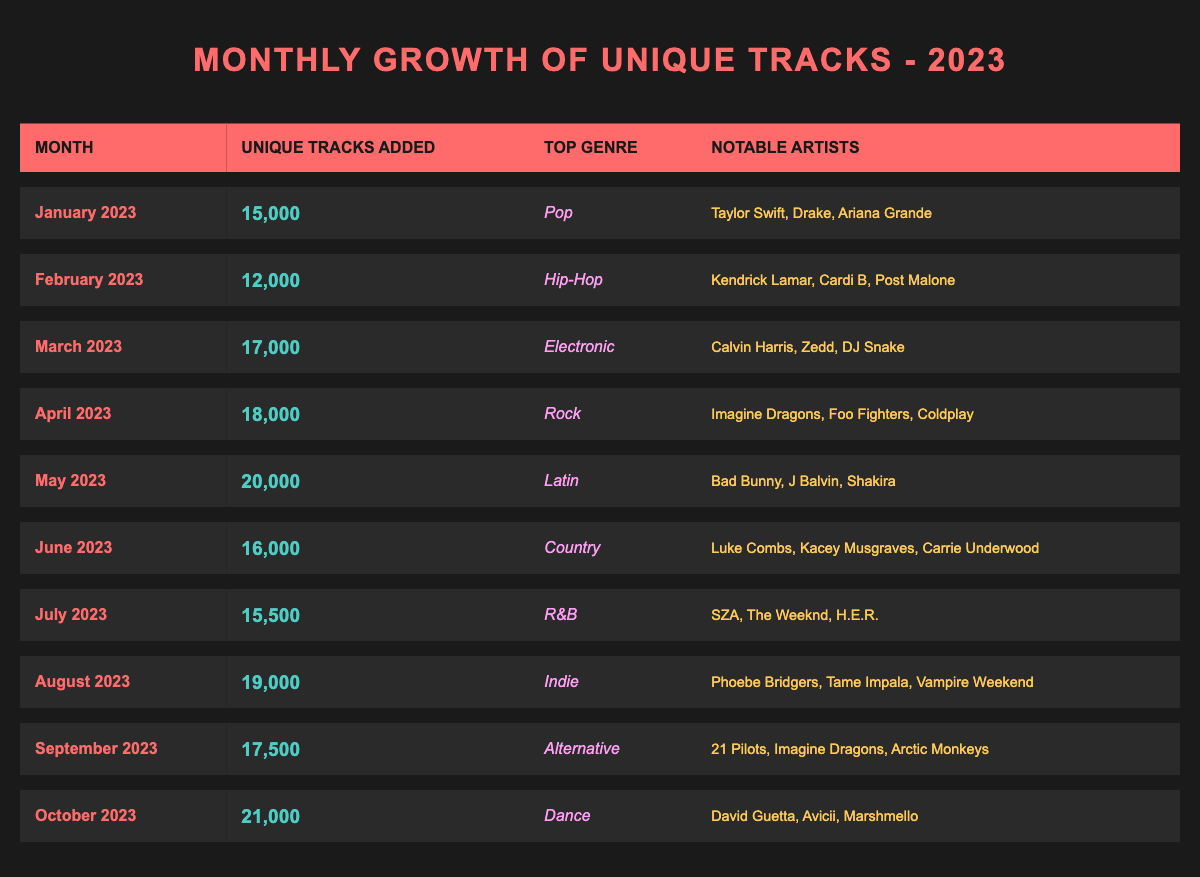What was the month with the highest number of unique tracks added? By examining the "Unique Tracks Added" column, I can see that October 2023 has the highest value of 21,000 unique tracks added.
Answer: October 2023 Which genre was the top genre in May 2023? Referring to the "Top Genre" column for May 2023, it shows Latin as the leading genre for that month.
Answer: Latin How many unique tracks were added in total from January to March 2023? To find the total, I add the unique tracks for January (15,000), February (12,000), and March (17,000): 15,000 + 12,000 + 17,000 = 44,000.
Answer: 44,000 Was there a decrease in the number of unique tracks added from January to February 2023? I compare the unique tracks added in January (15,000) to those in February (12,000). Since 12,000 is less than 15,000, there was indeed a decrease.
Answer: Yes What is the average number of unique tracks added from June to August 2023? First, I need to calculate the total for June (16,000), July (15,500), and August (19,000): 16,000 + 15,500 + 19,000 = 50,500. Then I divide by 3 (the number of months): 50,500 / 3 = 16,833.33.
Answer: 16,833 (rounded) Which month had more unique tracks added, July or September 2023? July saw 15,500 unique tracks added, while September had 17,500. Since 17,500 is greater than 15,500, September had more added tracks.
Answer: September What was the difference in unique tracks added between the months with the lowest and highest additions? The lowest addition was in February 2023 with 12,000 tracks, and the highest was in October 2023 with 21,000 tracks. The difference is 21,000 - 12,000 = 9,000.
Answer: 9,000 Which notable artist is associated with the top genre in April 2023? For April 2023, the top genre is Rock, and notable artists listed are Imagine Dragons, Foo Fighters, and Coldplay.
Answer: Imagine Dragons, Foo Fighters, Coldplay How many total unique tracks were added from May to October 2023? I need to find the total for May (20,000), June (16,000), July (15,500), August (19,000), September (17,500), and October (21,000). The total is: 20,000 + 16,000 + 15,500 + 19,000 + 17,500 + 21,000 = 109,000.
Answer: 109,000 Is it true that the top artist in the top genre of March 2023 was Calvin Harris? In March 2023, the top genre was Electronic, and Calvin Harris is listed as a notable artist for that genre, indicating that the statement is true.
Answer: Yes What genre had the highest number of unique tracks added in a single month in 2023? By checking the table, I see that October 2023 with the Dance genre had the highest unique tracks added at 21,000.
Answer: Dance 